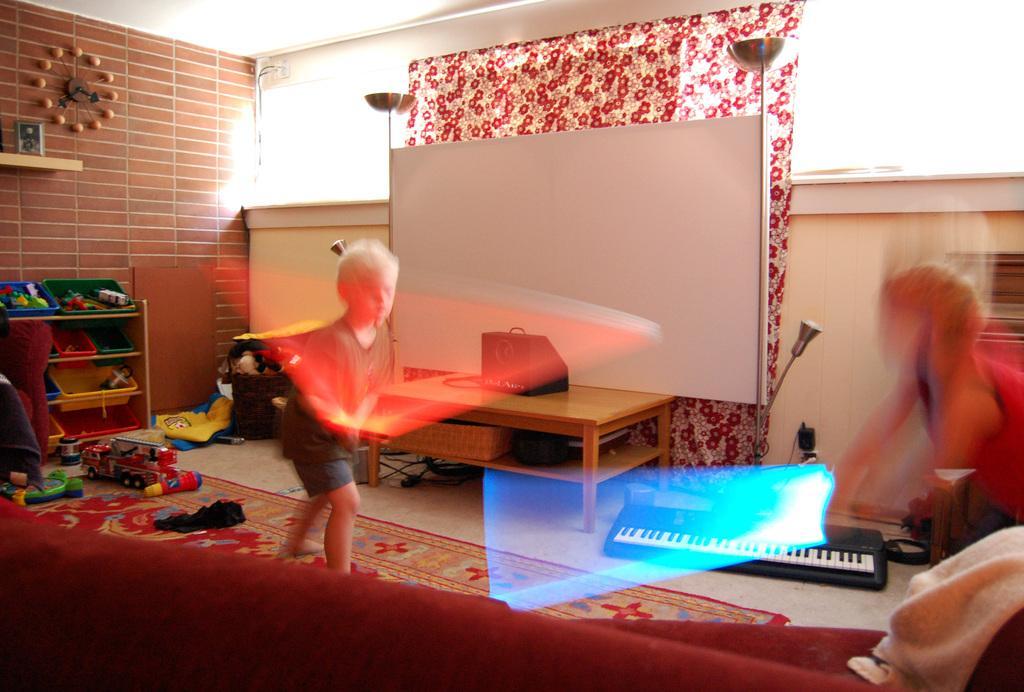How would you summarize this image in a sentence or two? Two boys are playing with toys in a living room. 